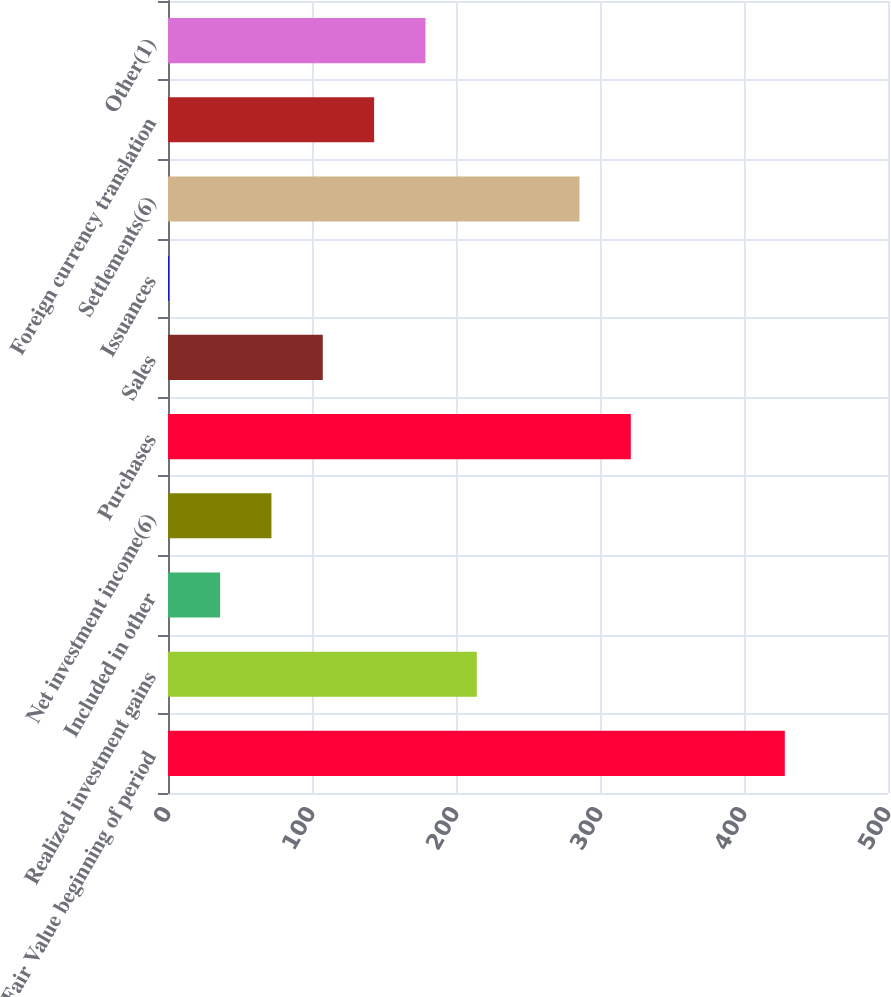Convert chart to OTSL. <chart><loc_0><loc_0><loc_500><loc_500><bar_chart><fcel>Fair Value beginning of period<fcel>Realized investment gains<fcel>Included in other<fcel>Net investment income(6)<fcel>Purchases<fcel>Sales<fcel>Issuances<fcel>Settlements(6)<fcel>Foreign currency translation<fcel>Other(1)<nl><fcel>428.34<fcel>214.44<fcel>36.19<fcel>71.84<fcel>321.39<fcel>107.49<fcel>0.54<fcel>285.74<fcel>143.14<fcel>178.79<nl></chart> 